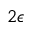Convert formula to latex. <formula><loc_0><loc_0><loc_500><loc_500>2 \epsilon</formula> 